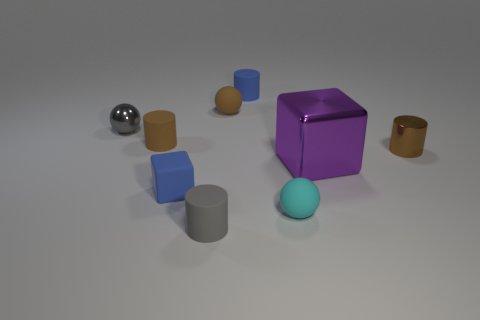Subtract all tiny shiny balls. How many balls are left? 2 Subtract all gray balls. How many balls are left? 2 Subtract 2 cubes. How many cubes are left? 0 Subtract all purple blocks. How many brown cylinders are left? 2 Subtract all spheres. How many objects are left? 6 Add 1 large green metal spheres. How many objects exist? 10 Add 3 large metal cubes. How many large metal cubes exist? 4 Subtract 0 cyan blocks. How many objects are left? 9 Subtract all purple spheres. Subtract all blue cylinders. How many spheres are left? 3 Subtract all gray shiny balls. Subtract all small blue matte cylinders. How many objects are left? 7 